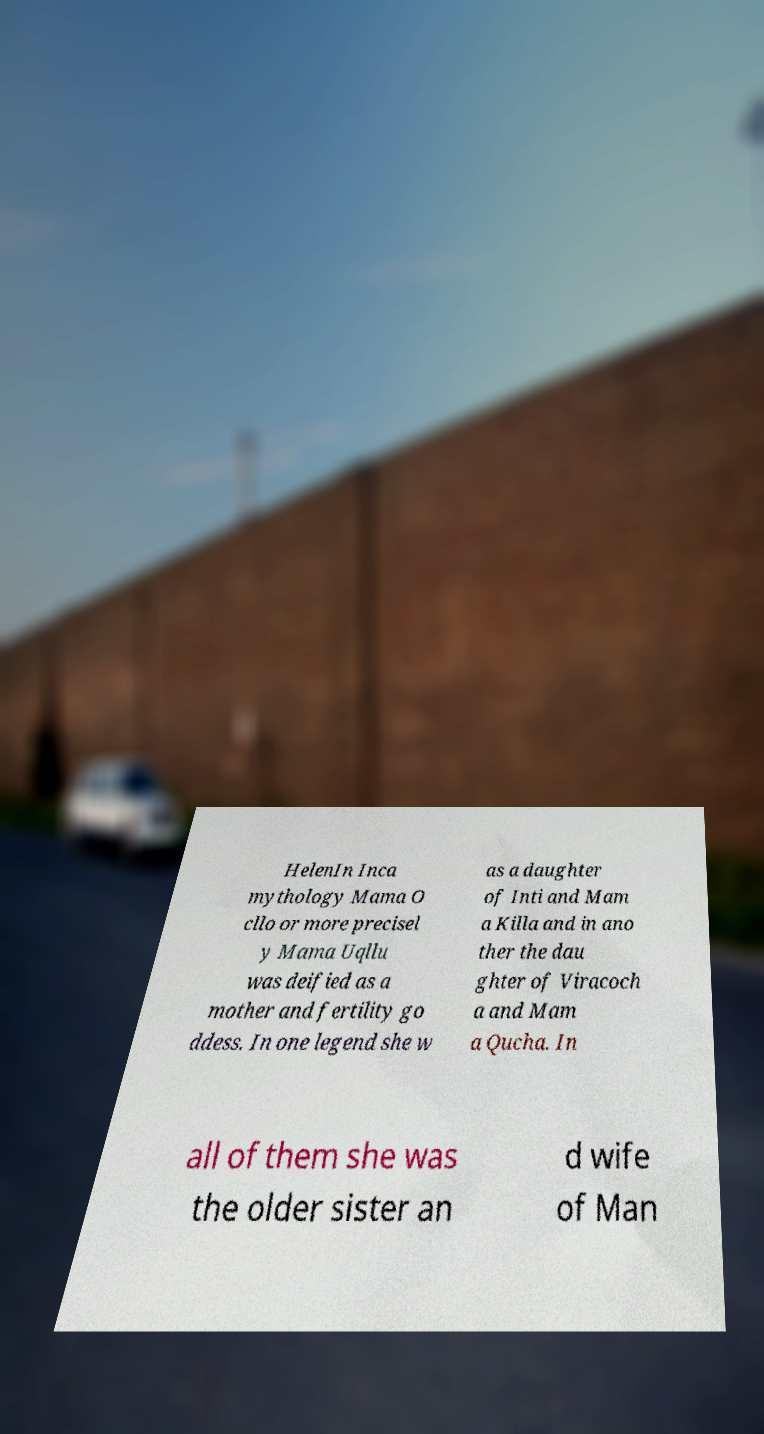Please read and relay the text visible in this image. What does it say? HelenIn Inca mythology Mama O cllo or more precisel y Mama Uqllu was deified as a mother and fertility go ddess. In one legend she w as a daughter of Inti and Mam a Killa and in ano ther the dau ghter of Viracoch a and Mam a Qucha. In all of them she was the older sister an d wife of Man 